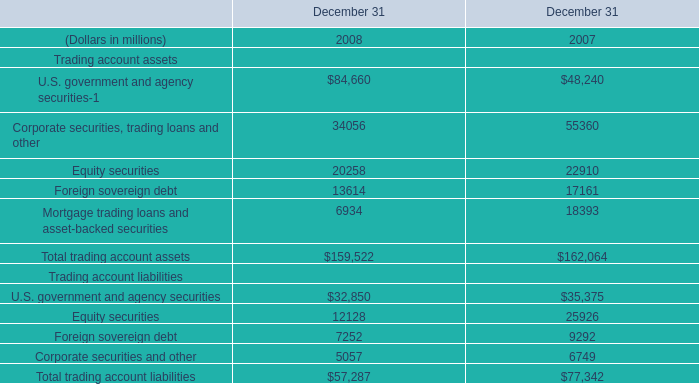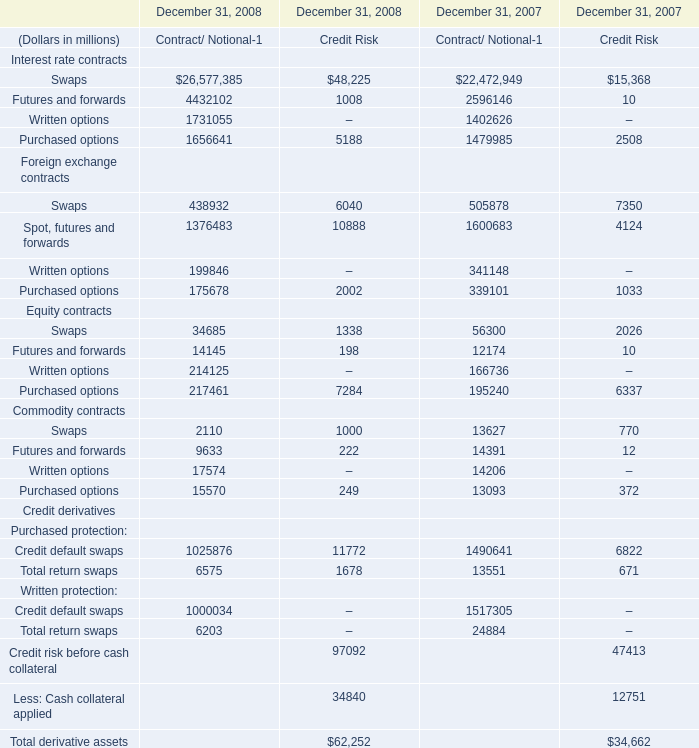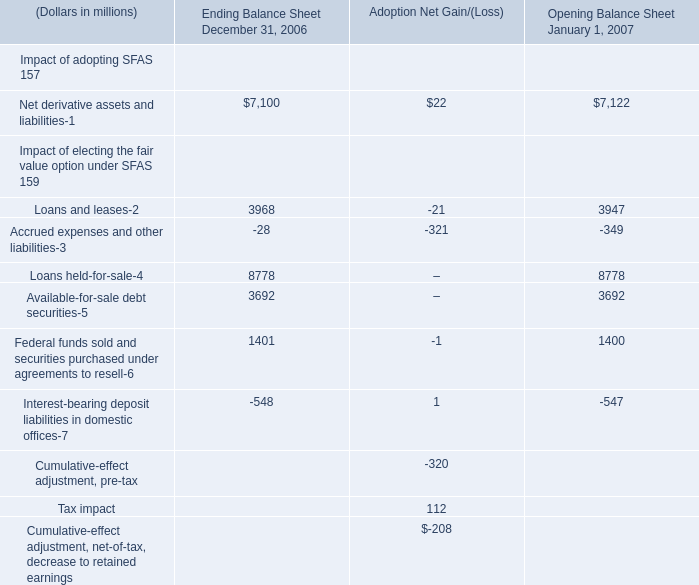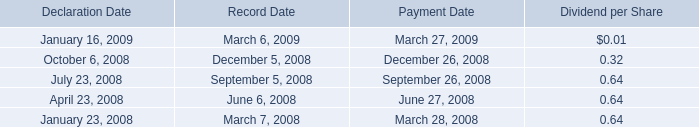What will Written options be like in 2009 if it develops with the same increasing rate as current? (in million) 
Computations: ((((1731055 - 1402626) / 1731055) * 1731055) + 1731055)
Answer: 2059484.0. 